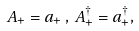Convert formula to latex. <formula><loc_0><loc_0><loc_500><loc_500>A _ { + } = a _ { + } \, , \, A _ { + } ^ { \dagger } = a _ { + } ^ { \dagger } ,</formula> 